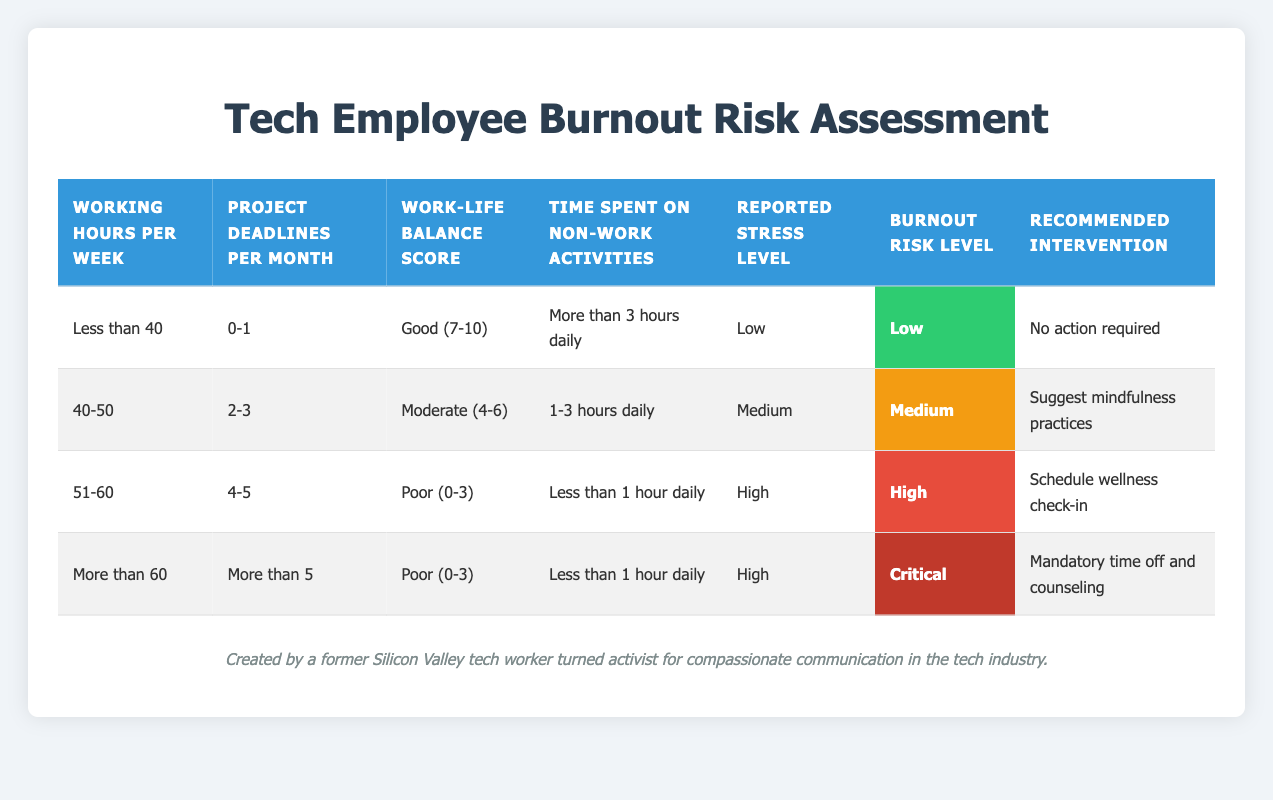What is the burnout risk level for employees who work less than 40 hours per week? Referring to the first row of the table, employees working less than 40 hours per week have a burnout risk level of "Low."
Answer: Low How many different recommended interventions are listed in the table? The table lists four different recommended interventions: "No action required," "Suggest mindfulness practices," "Schedule wellness check-in," and "Mandatory time off and counseling." Thus, the total is 4.
Answer: 4 What is the combination of conditions that lead to a "Critical" burnout risk level? The "Critical" burnout risk level is present in the last row, which corresponds to the conditions: "More than 60" working hours per week, "More than 5" project deadlines per month, "Poor (0-3)" work-life balance score, and "High" reported stress level.
Answer: More than 60 working hours, More than 5 project deadlines, Poor work-life balance, High stress level Is it true that having a "Good" work-life balance score always results in a "Low" burnout risk level? No, it is not true. While the first row shows that a "Good" work-life balance score leads to a "Low" burnout risk, other conditions are needed for this outcome. Therefore, a "Good" score does not guarantee "Low" risk.
Answer: No What is the reported stress level for an employee with a "High" burnout risk level? According to the table, the row showing "High" burnout risk level indicates a "High" reported stress level, as seen in both the third and fourth rows.
Answer: High What would the recommended intervention be for an employee with a "Medium" burnout risk level? The second row indicates that employees with a "Medium" burnout risk level should receive the intervention "Suggest mindfulness practices."
Answer: Suggest mindfulness practices What are the working hours per week and project deadlines per month for someone who requires a scheduled wellness check-in? The row that requires a scheduled wellness check-in indicates that the working hours per week are "51-60" and the project deadlines per month are "4-5."
Answer: 51-60 working hours, 4-5 project deadlines If an employee works more than 60 hours per week but has a Good work-life balance score, what would be their burnout risk level? Although working more than 60 hours and having a Good work-life balance appears relevant, there is no direct row in the table to indicate this combination since the critical burnout risk requires a "Poor" work-life balance. Hence, we cannot determine their risk level as "Low."
Answer: Unknown How many conditions are checked for determining burnout risk levels? There are five conditions checked: working hours per week, project deadlines per month, work-life balance score, time spent on non-work activities, and reported stress level. Summing these gives a total of 5 conditions.
Answer: 5 